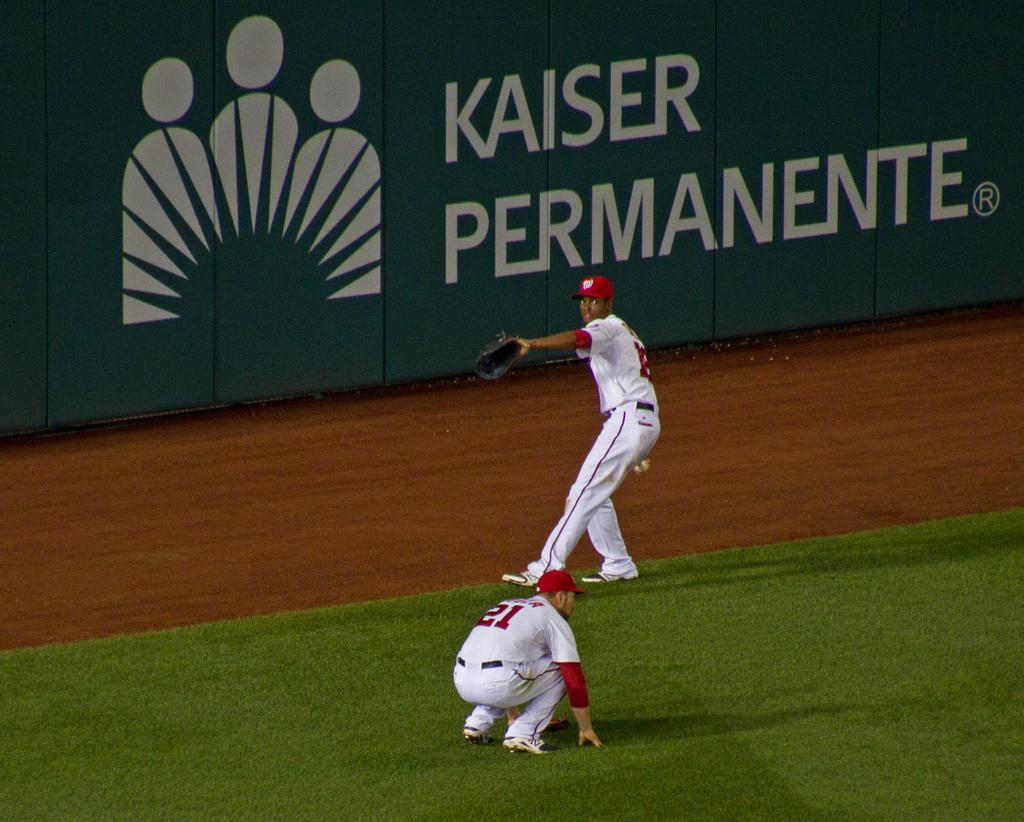What is the sponsor on the green wall?
Your answer should be very brief. Kaiser permanente. What is the jersey number of the player in front?
Make the answer very short. 21. 